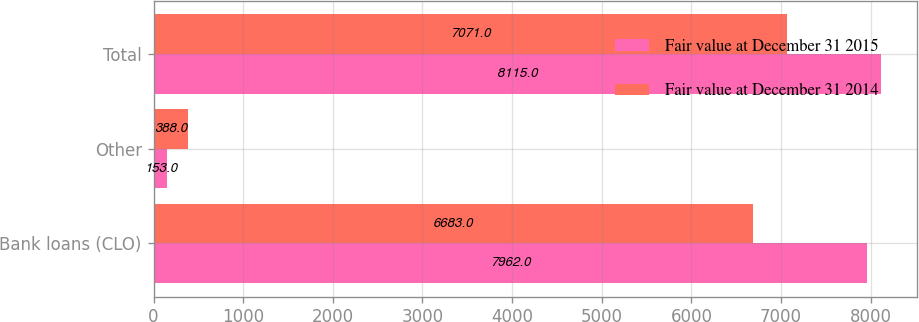<chart> <loc_0><loc_0><loc_500><loc_500><stacked_bar_chart><ecel><fcel>Bank loans (CLO)<fcel>Other<fcel>Total<nl><fcel>Fair value at December 31 2015<fcel>7962<fcel>153<fcel>8115<nl><fcel>Fair value at December 31 2014<fcel>6683<fcel>388<fcel>7071<nl></chart> 